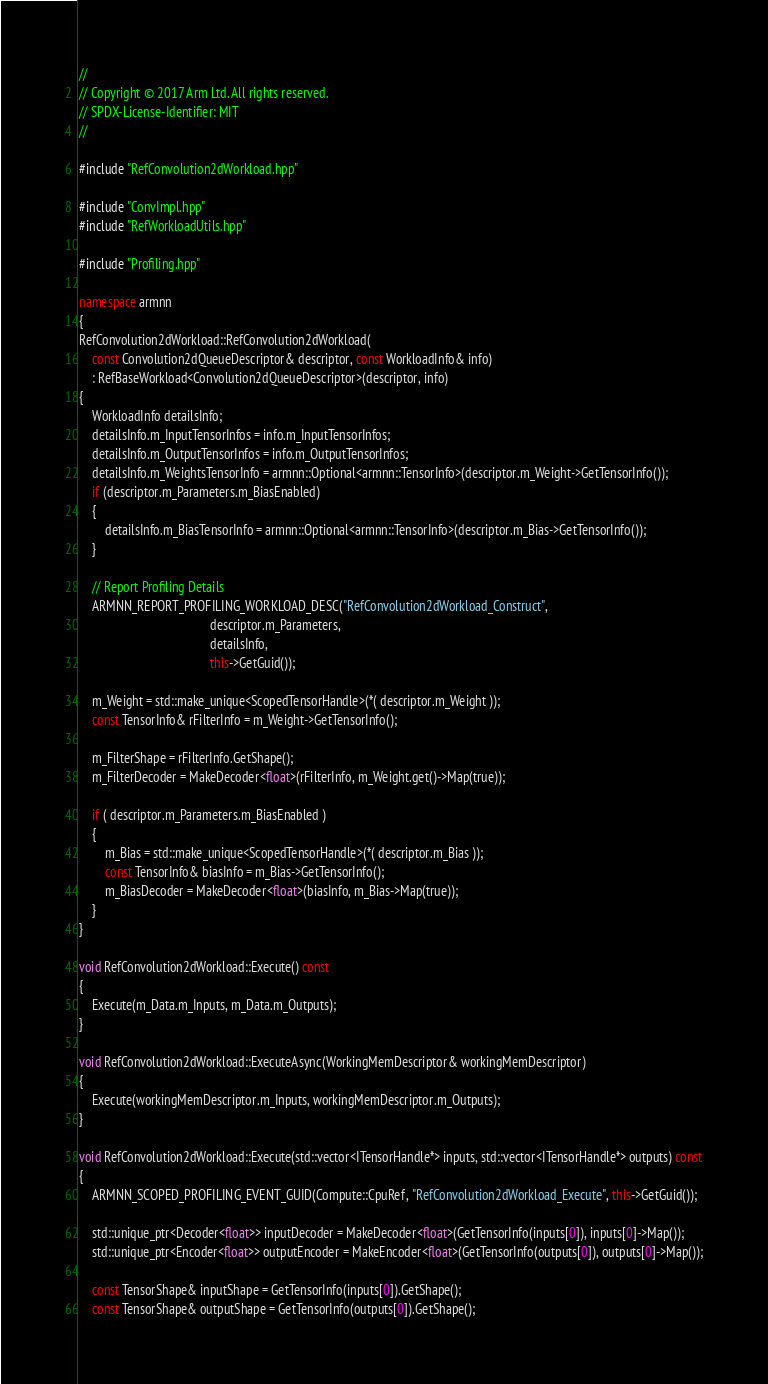Convert code to text. <code><loc_0><loc_0><loc_500><loc_500><_C++_>//
// Copyright © 2017 Arm Ltd. All rights reserved.
// SPDX-License-Identifier: MIT
//

#include "RefConvolution2dWorkload.hpp"

#include "ConvImpl.hpp"
#include "RefWorkloadUtils.hpp"

#include "Profiling.hpp"

namespace armnn
{
RefConvolution2dWorkload::RefConvolution2dWorkload(
    const Convolution2dQueueDescriptor& descriptor, const WorkloadInfo& info)
    : RefBaseWorkload<Convolution2dQueueDescriptor>(descriptor, info)
{
    WorkloadInfo detailsInfo;
    detailsInfo.m_InputTensorInfos = info.m_InputTensorInfos;
    detailsInfo.m_OutputTensorInfos = info.m_OutputTensorInfos;
    detailsInfo.m_WeightsTensorInfo = armnn::Optional<armnn::TensorInfo>(descriptor.m_Weight->GetTensorInfo());
    if (descriptor.m_Parameters.m_BiasEnabled)
    {
        detailsInfo.m_BiasTensorInfo = armnn::Optional<armnn::TensorInfo>(descriptor.m_Bias->GetTensorInfo());
    }

    // Report Profiling Details
    ARMNN_REPORT_PROFILING_WORKLOAD_DESC("RefConvolution2dWorkload_Construct",
                                         descriptor.m_Parameters,
                                         detailsInfo,
                                         this->GetGuid());

    m_Weight = std::make_unique<ScopedTensorHandle>(*( descriptor.m_Weight ));
    const TensorInfo& rFilterInfo = m_Weight->GetTensorInfo();

    m_FilterShape = rFilterInfo.GetShape();
    m_FilterDecoder = MakeDecoder<float>(rFilterInfo, m_Weight.get()->Map(true));

    if ( descriptor.m_Parameters.m_BiasEnabled )
    {
        m_Bias = std::make_unique<ScopedTensorHandle>(*( descriptor.m_Bias ));
        const TensorInfo& biasInfo = m_Bias->GetTensorInfo();
        m_BiasDecoder = MakeDecoder<float>(biasInfo, m_Bias->Map(true));
    }
}

void RefConvolution2dWorkload::Execute() const
{
    Execute(m_Data.m_Inputs, m_Data.m_Outputs);
}

void RefConvolution2dWorkload::ExecuteAsync(WorkingMemDescriptor& workingMemDescriptor)
{
    Execute(workingMemDescriptor.m_Inputs, workingMemDescriptor.m_Outputs);
}

void RefConvolution2dWorkload::Execute(std::vector<ITensorHandle*> inputs, std::vector<ITensorHandle*> outputs) const
{
    ARMNN_SCOPED_PROFILING_EVENT_GUID(Compute::CpuRef, "RefConvolution2dWorkload_Execute", this->GetGuid());

    std::unique_ptr<Decoder<float>> inputDecoder = MakeDecoder<float>(GetTensorInfo(inputs[0]), inputs[0]->Map());
    std::unique_ptr<Encoder<float>> outputEncoder = MakeEncoder<float>(GetTensorInfo(outputs[0]), outputs[0]->Map());

    const TensorShape& inputShape = GetTensorInfo(inputs[0]).GetShape();
    const TensorShape& outputShape = GetTensorInfo(outputs[0]).GetShape();
</code> 